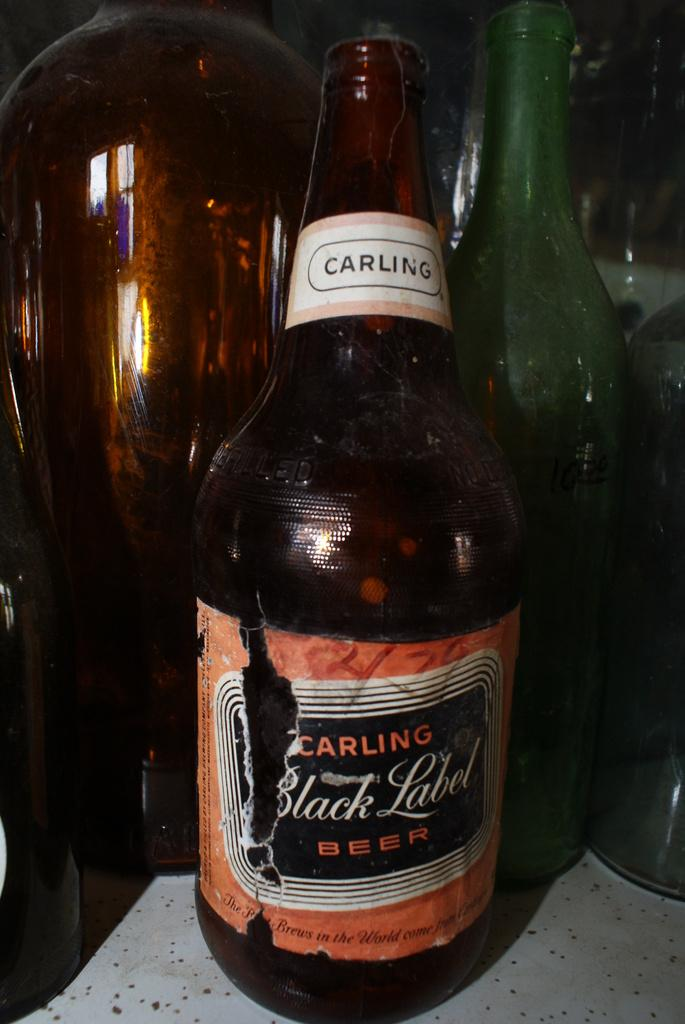<image>
Render a clear and concise summary of the photo. a bottle of carling black label beer in front of some other bottles 